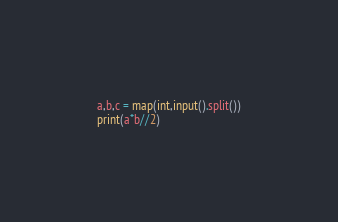Convert code to text. <code><loc_0><loc_0><loc_500><loc_500><_Python_>a,b,c = map(int,input().split())
print(a*b//2)</code> 